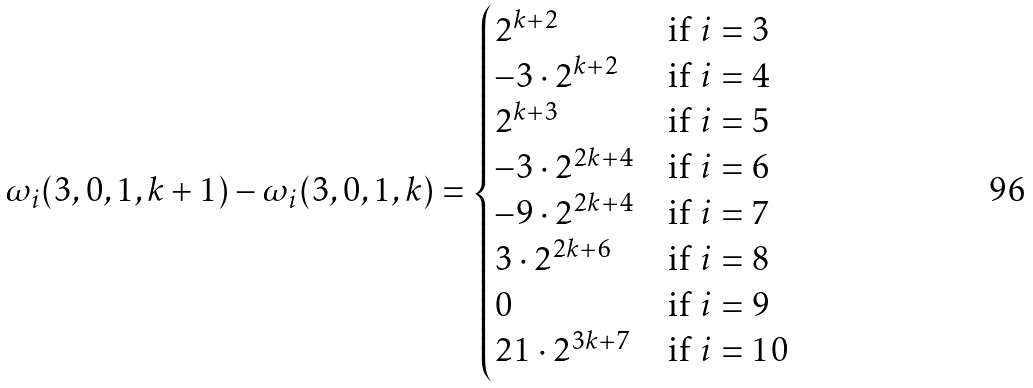<formula> <loc_0><loc_0><loc_500><loc_500>\omega _ { i } ( 3 , 0 , 1 , k + 1 ) - \omega _ { i } ( 3 , 0 , 1 , k ) = \begin{cases} 2 ^ { k + 2 } & \text {if } i = 3 \\ - 3 \cdot 2 ^ { k + 2 } & \text {if } i = 4 \\ 2 ^ { k + 3 } & \text {if } i = 5 \\ - 3 \cdot 2 ^ { 2 k + 4 } & \text {if } i = 6 \\ - 9 \cdot 2 ^ { 2 k + 4 } & \text {if } i = 7 \\ 3 \cdot 2 ^ { 2 k + 6 } & \text {if } i = 8 \\ 0 & \text {if } i = 9 \\ 2 1 \cdot 2 ^ { 3 k + 7 } & \text {if } i = 1 0 \end{cases}</formula> 